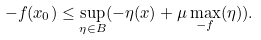<formula> <loc_0><loc_0><loc_500><loc_500>- f ( x _ { 0 } ) \leq \sup _ { \eta \in B } ( - \eta ( x ) + \mu \max _ { - f } ( \eta ) ) .</formula> 